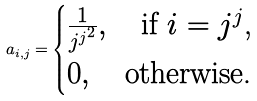<formula> <loc_0><loc_0><loc_500><loc_500>a _ { i , j } = \begin{cases} \frac { 1 } { j ^ { j ^ { 2 } } } , \quad \text {if $i=j^{j}$,} \\ 0 , \quad \text {otherwise.} \\ \end{cases}</formula> 